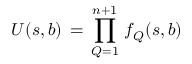<formula> <loc_0><loc_0><loc_500><loc_500>U ( s , b ) \, = \, \prod _ { Q = 1 } ^ { n + 1 } \, f _ { Q } ( s , b )</formula> 